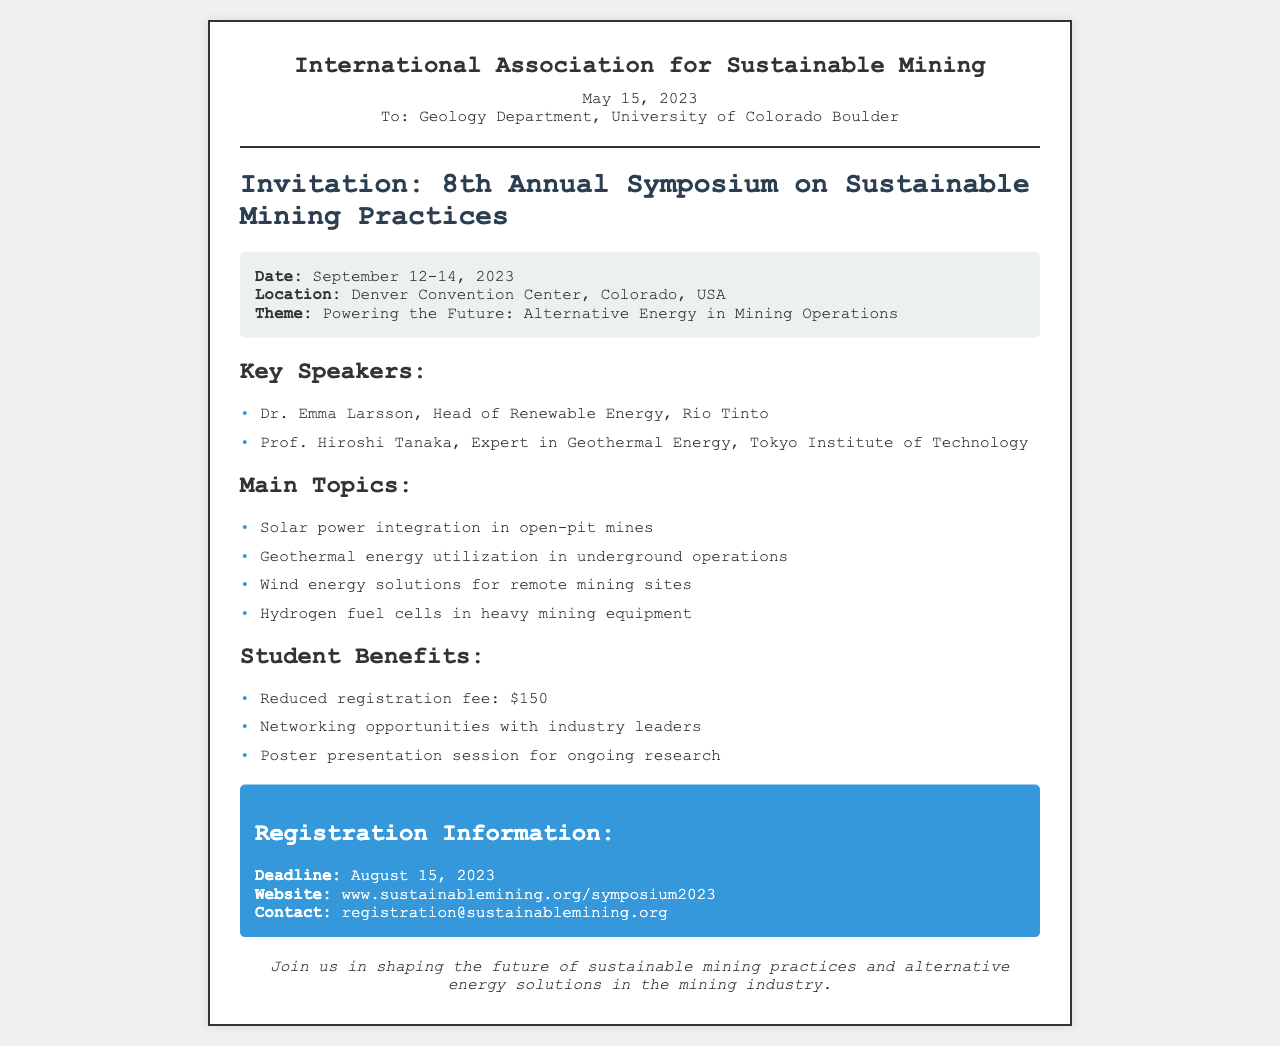What is the date of the symposium? The date of the symposium is provided in the event details section, which specifies September 12-14, 2023.
Answer: September 12-14, 2023 Who is a key speaker from Rio Tinto? The speaker list mentions Dr. Emma Larsson, who is the Head of Renewable Energy at Rio Tinto.
Answer: Dr. Emma Larsson What is the theme of the symposium? The theme is outlined in the event details section as "Powering the Future: Alternative Energy in Mining Operations."
Answer: Powering the Future: Alternative Energy in Mining Operations What is the student registration fee? The benefits section lists the student registration fee as $150.
Answer: $150 What is the registration deadline? The registration information states that the deadline is August 15, 2023.
Answer: August 15, 2023 What type of energy solutions are discussed for remote mining sites? The main topics section specifically mentions wind energy solutions for remote mining sites.
Answer: Wind energy solutions for remote mining sites Who is the expert in geothermal energy? The document lists Prof. Hiroshi Tanaka from the Tokyo Institute of Technology as the expert in geothermal energy.
Answer: Prof. Hiroshi Tanaka Where will the symposium be held? The event details indicate that the symposium will take place at the Denver Convention Center, Colorado, USA.
Answer: Denver Convention Center, Colorado, USA 